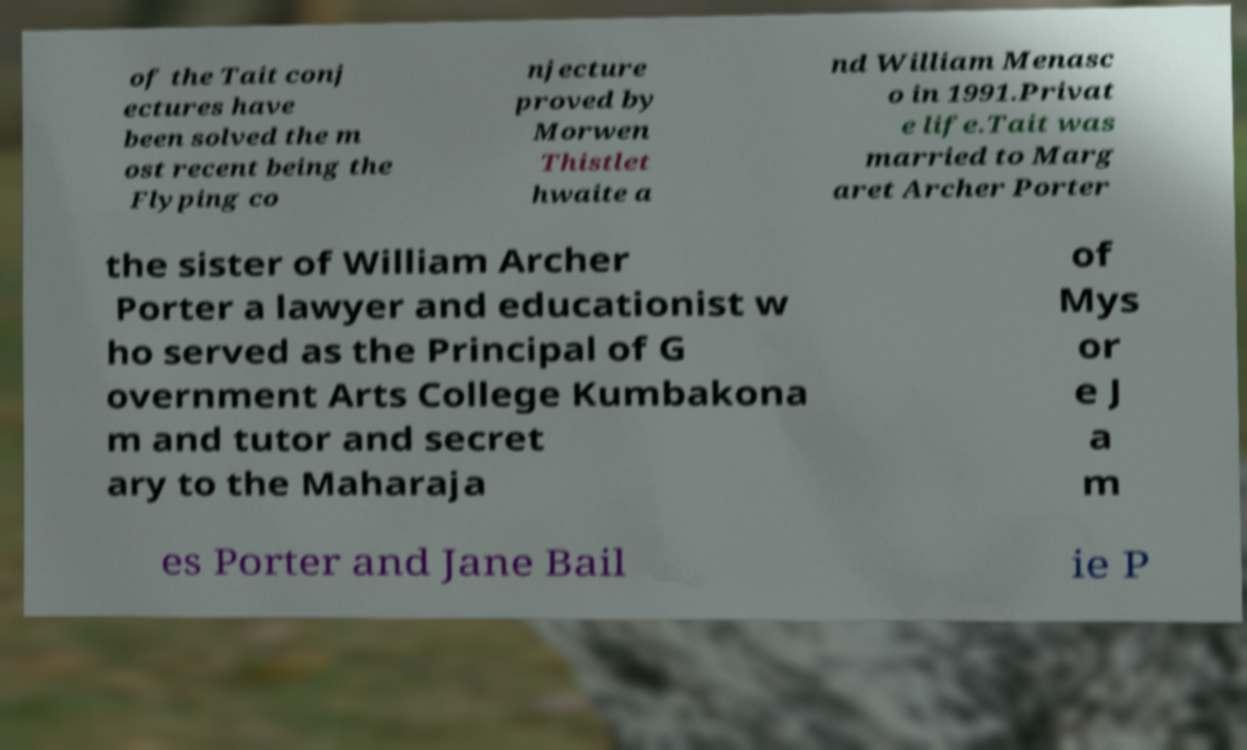Please read and relay the text visible in this image. What does it say? of the Tait conj ectures have been solved the m ost recent being the Flyping co njecture proved by Morwen Thistlet hwaite a nd William Menasc o in 1991.Privat e life.Tait was married to Marg aret Archer Porter the sister of William Archer Porter a lawyer and educationist w ho served as the Principal of G overnment Arts College Kumbakona m and tutor and secret ary to the Maharaja of Mys or e J a m es Porter and Jane Bail ie P 